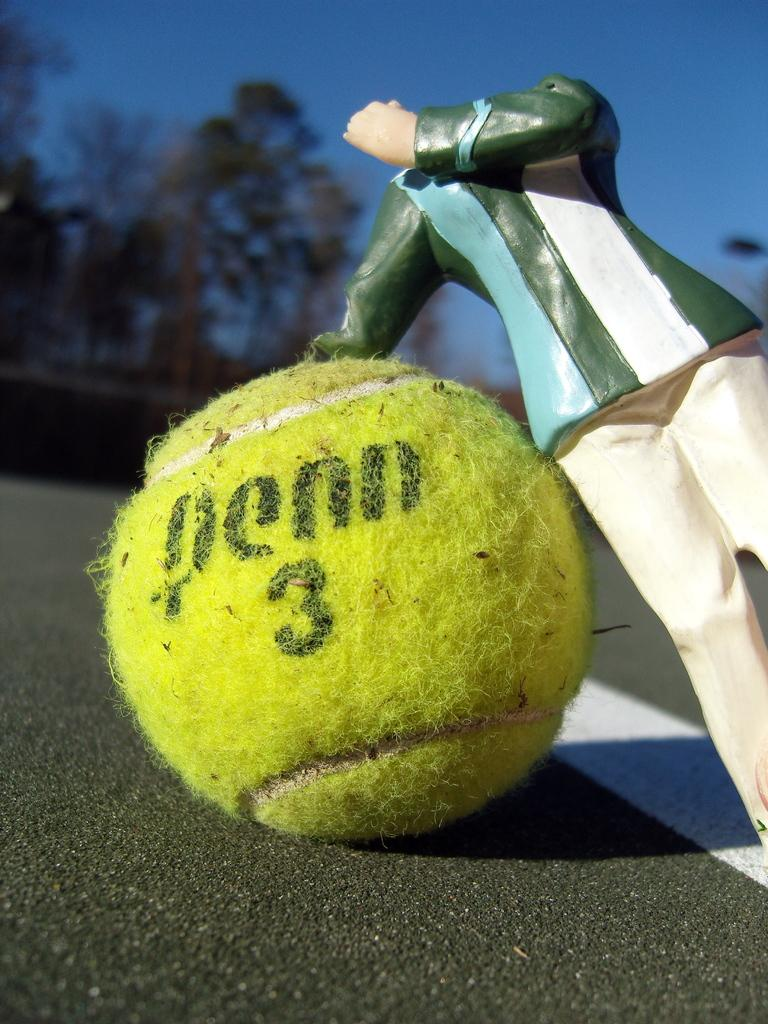<image>
Share a concise interpretation of the image provided. A headless action figure rests on a Penn 3 tennis ball. 